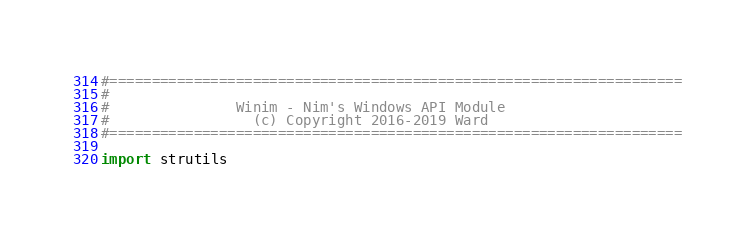Convert code to text. <code><loc_0><loc_0><loc_500><loc_500><_Nim_>#====================================================================
#
#               Winim - Nim's Windows API Module
#                 (c) Copyright 2016-2019 Ward
#====================================================================

import strutils</code> 